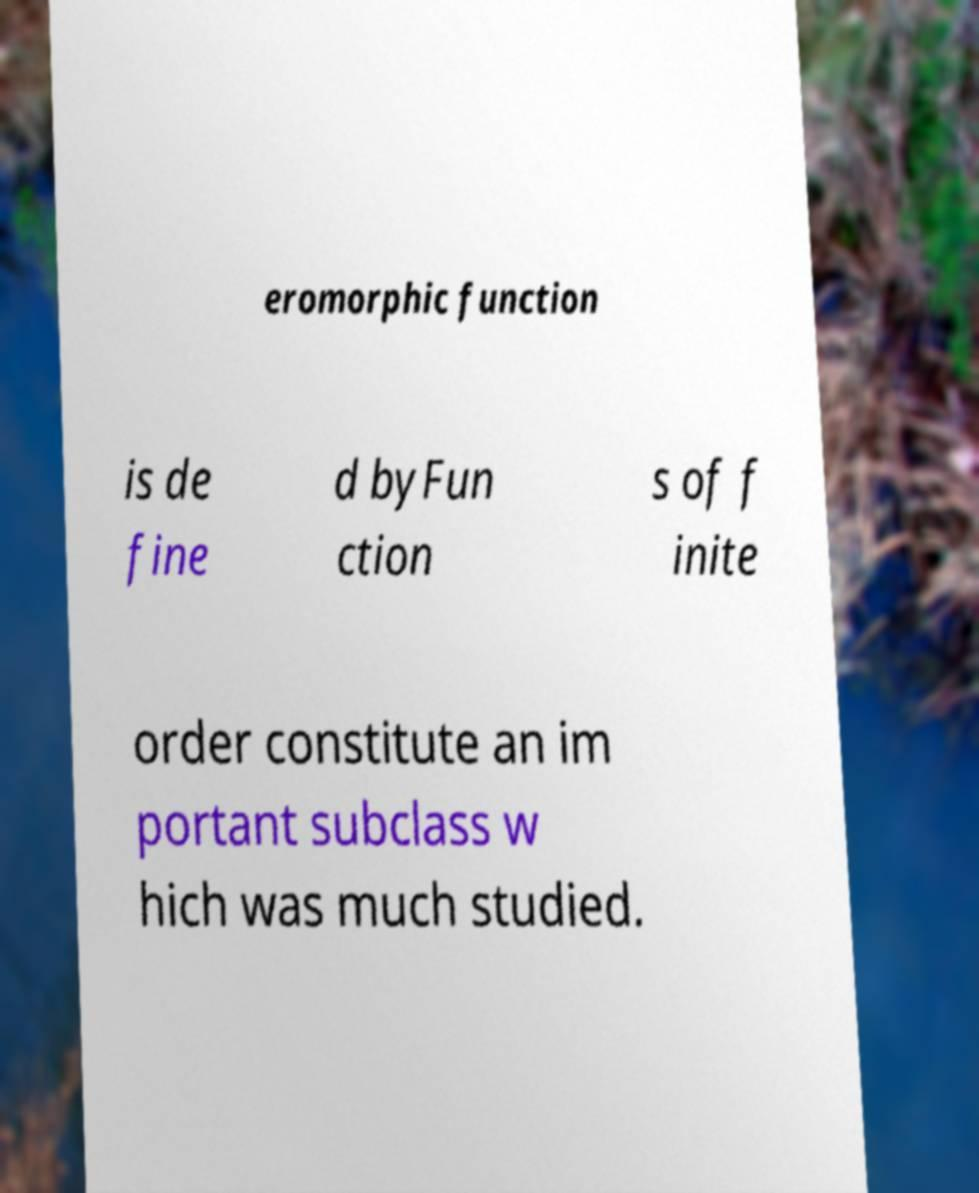Could you assist in decoding the text presented in this image and type it out clearly? eromorphic function is de fine d byFun ction s of f inite order constitute an im portant subclass w hich was much studied. 